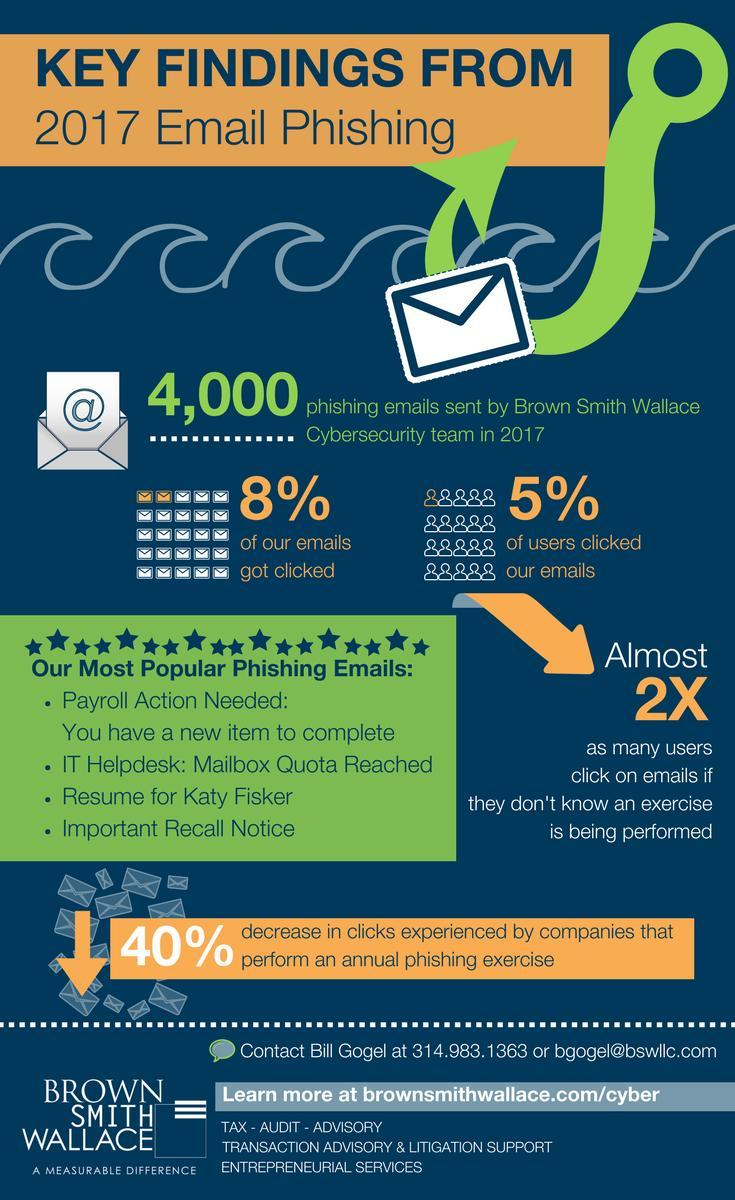Which is the third most popular phishing email?
Answer the question with a short phrase. resume for Katy Fiskar Which is the fourth most popular phishing email? Important recall notice 